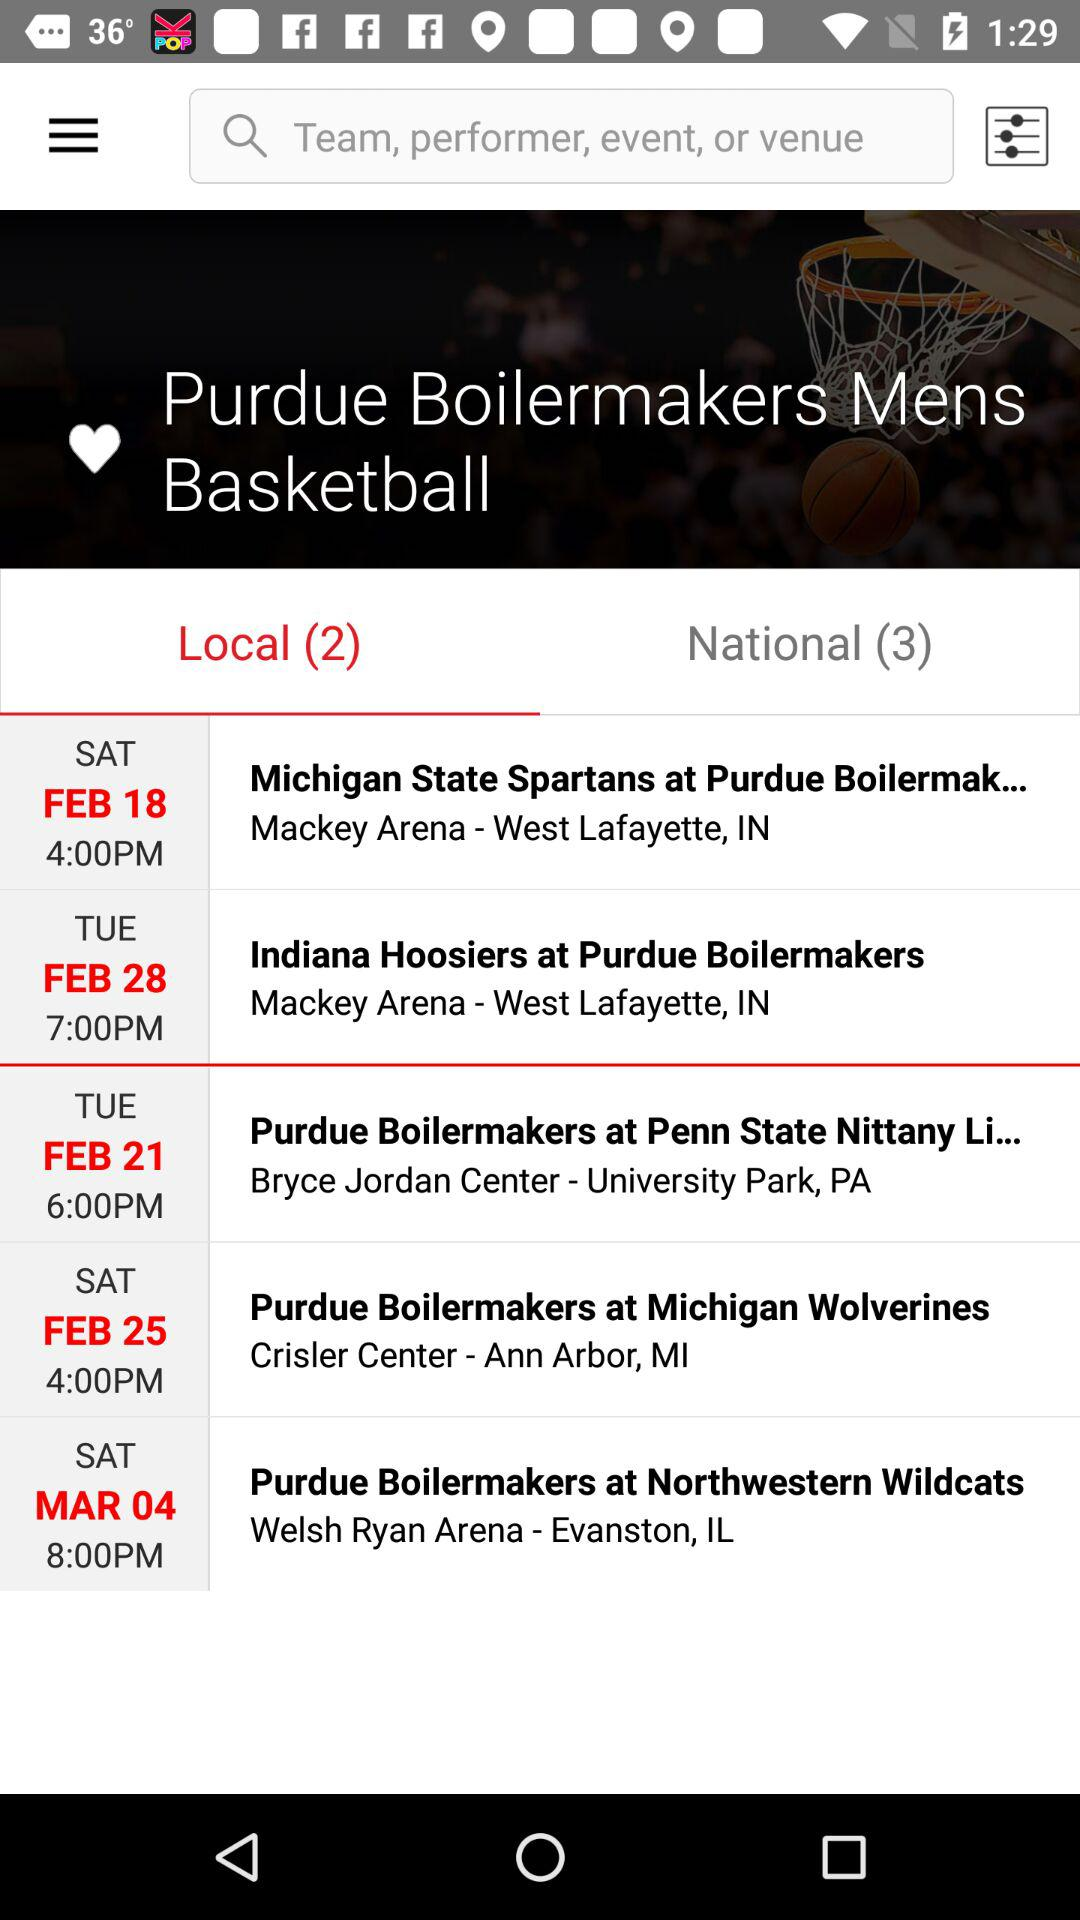Which tab is selected? The selected tab is "Local". 